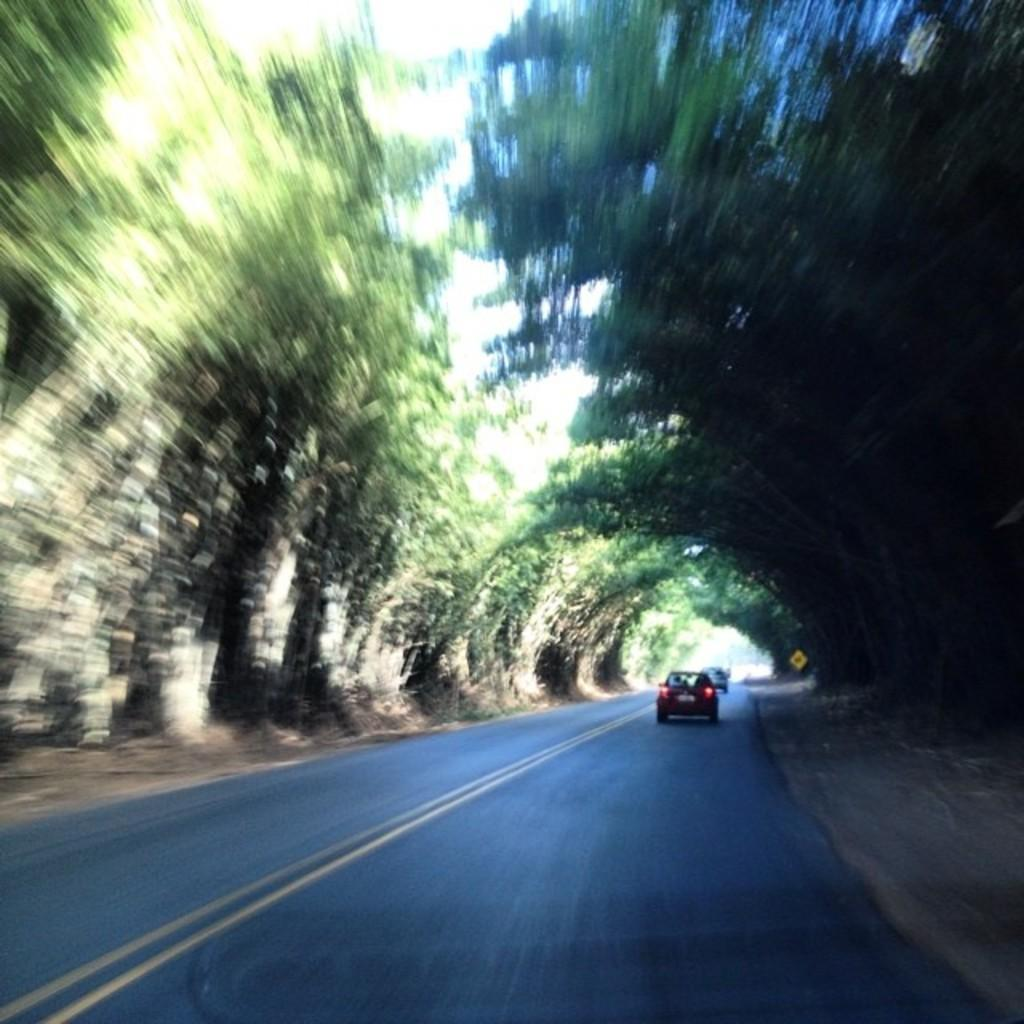What is in the foreground of the image? There is a road in the foreground of the image. What is happening on the road? There are cars on the road. What type of vegetation can be seen in the image? Trees are visible in the image. What is unusual about the color of the trees in the image? The trees appear to be blue in the image. How many fields can be seen in the image? There are no fields visible in the image. What type of animal is grazing in the field in the image? There are no animals grazing in a field in the image, as there are no fields present. 